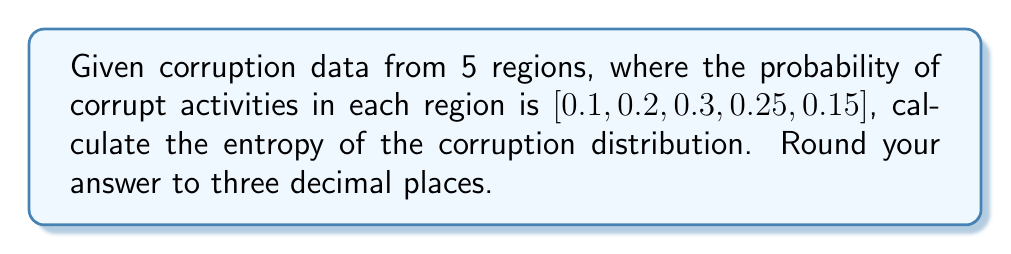What is the answer to this math problem? To calculate the entropy of the corruption distribution, we'll use the Shannon entropy formula:

$$ H = -\sum_{i=1}^{n} p_i \log_2(p_i) $$

Where:
$H$ is the entropy
$p_i$ is the probability of corrupt activities in region $i$
$n$ is the number of regions

Step 1: Calculate each term in the sum:
- Region 1: $-0.1 \log_2(0.1) = 0.3322$
- Region 2: $-0.2 \log_2(0.2) = 0.4644$
- Region 3: $-0.3 \log_2(0.3) = 0.5211$
- Region 4: $-0.25 \log_2(0.25) = 0.5000$
- Region 5: $-0.15 \log_2(0.15) = 0.4101$

Step 2: Sum all terms:
$$ H = 0.3322 + 0.4644 + 0.5211 + 0.5000 + 0.4101 = 2.2278 $$

Step 3: Round to three decimal places:
$$ H \approx 2.228 $$

This entropy value quantifies the uncertainty or randomness in the corruption distribution across the five regions.
Answer: 2.228 